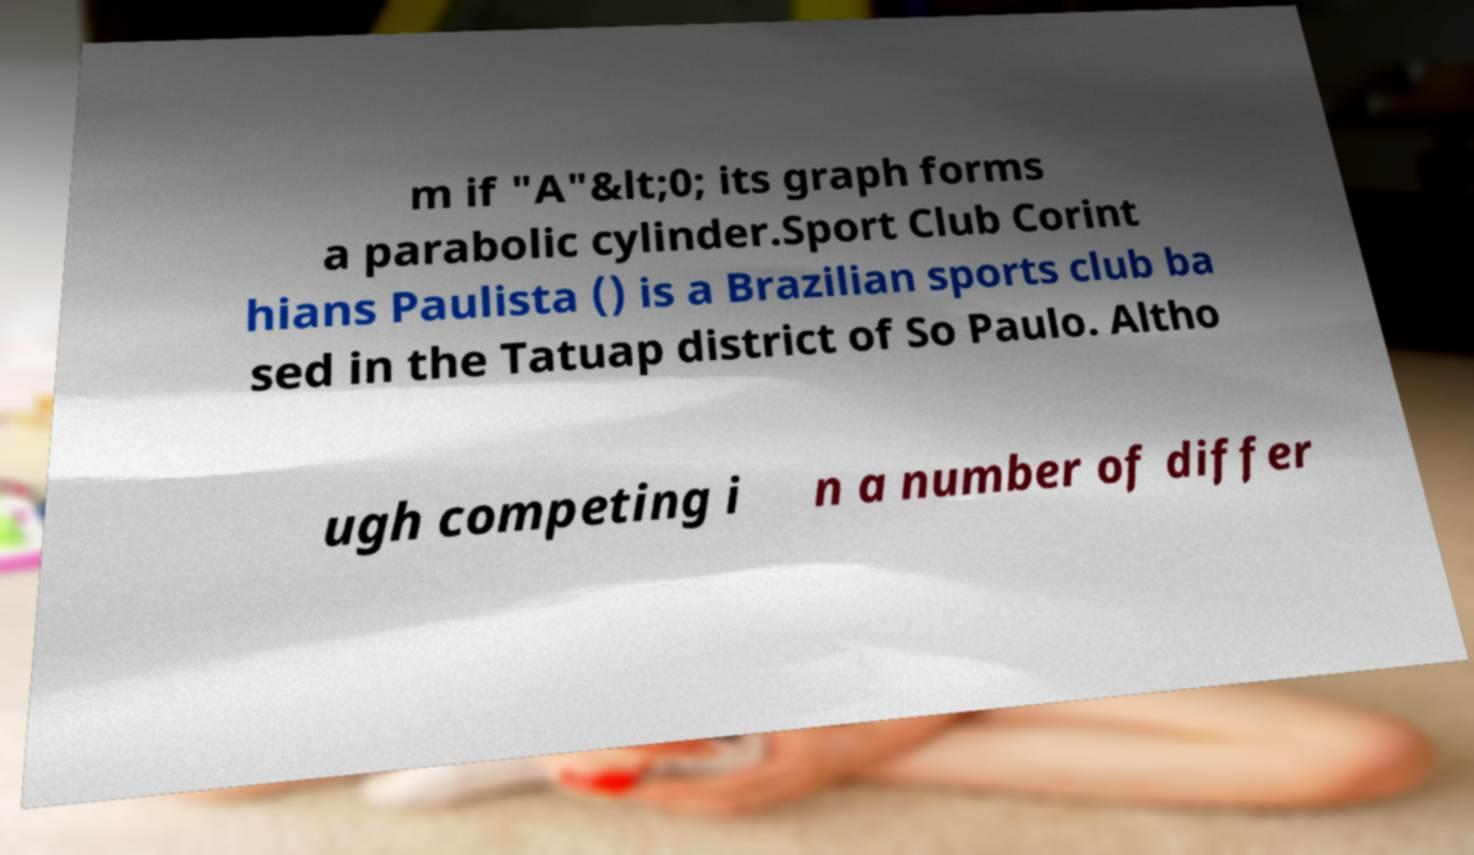What messages or text are displayed in this image? I need them in a readable, typed format. m if "A"&lt;0; its graph forms a parabolic cylinder.Sport Club Corint hians Paulista () is a Brazilian sports club ba sed in the Tatuap district of So Paulo. Altho ugh competing i n a number of differ 